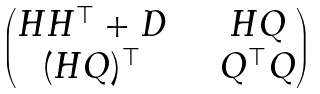Convert formula to latex. <formula><loc_0><loc_0><loc_500><loc_500>\begin{pmatrix} H H ^ { \top } + D & \quad H Q \\ ( H Q ) ^ { \top } & \quad Q ^ { \top } Q \end{pmatrix}</formula> 